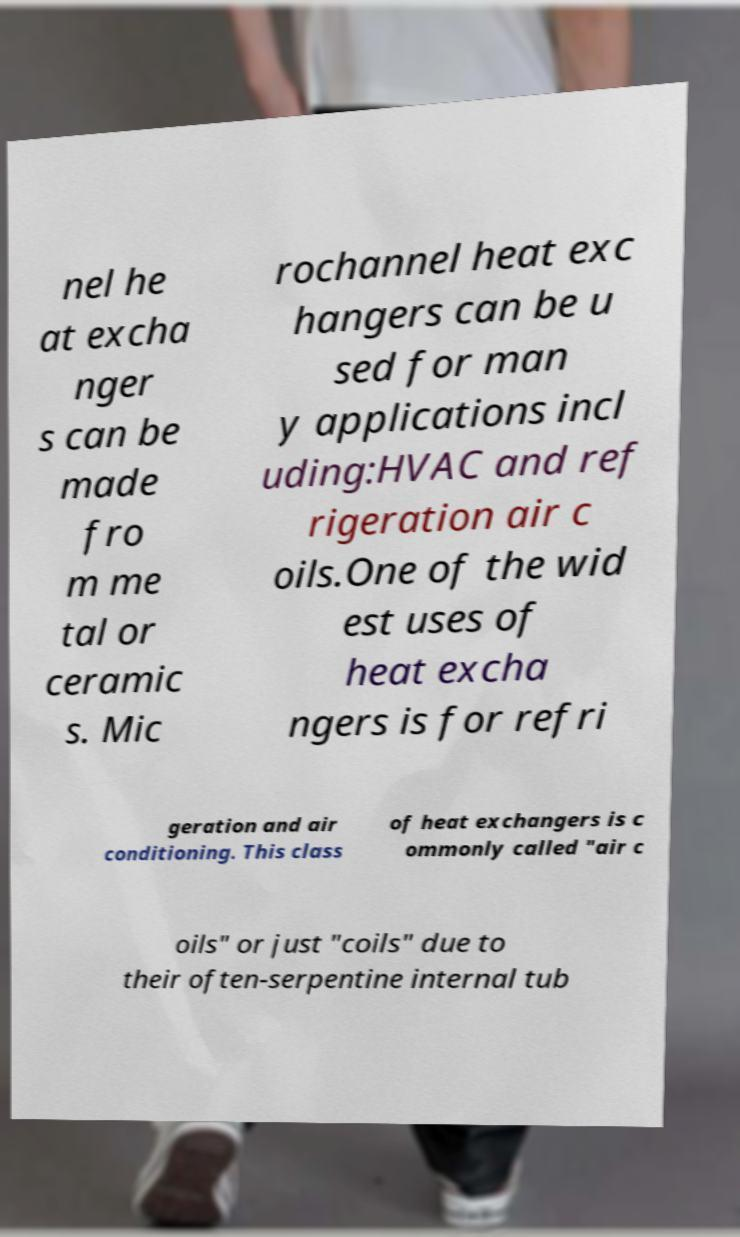Please read and relay the text visible in this image. What does it say? nel he at excha nger s can be made fro m me tal or ceramic s. Mic rochannel heat exc hangers can be u sed for man y applications incl uding:HVAC and ref rigeration air c oils.One of the wid est uses of heat excha ngers is for refri geration and air conditioning. This class of heat exchangers is c ommonly called "air c oils" or just "coils" due to their often-serpentine internal tub 